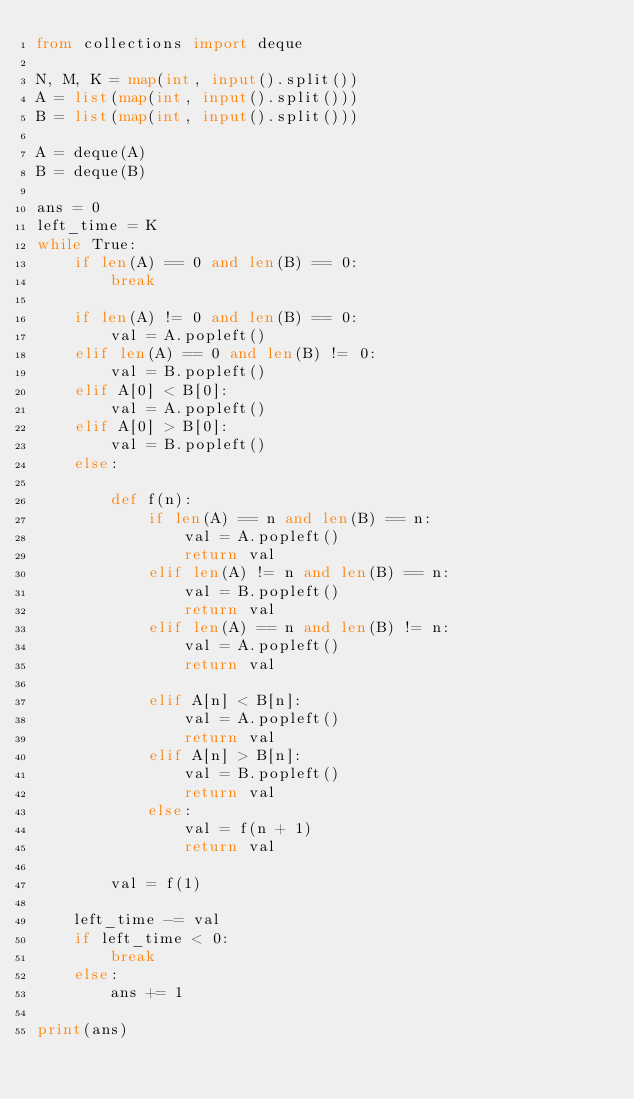Convert code to text. <code><loc_0><loc_0><loc_500><loc_500><_Python_>from collections import deque

N, M, K = map(int, input().split())
A = list(map(int, input().split()))
B = list(map(int, input().split()))

A = deque(A)
B = deque(B)

ans = 0
left_time = K
while True:
    if len(A) == 0 and len(B) == 0:
        break

    if len(A) != 0 and len(B) == 0:
        val = A.popleft()
    elif len(A) == 0 and len(B) != 0:
        val = B.popleft()
    elif A[0] < B[0]:
        val = A.popleft()
    elif A[0] > B[0]:
        val = B.popleft()
    else:

        def f(n):
            if len(A) == n and len(B) == n:
                val = A.popleft()
                return val
            elif len(A) != n and len(B) == n:
                val = B.popleft()
                return val
            elif len(A) == n and len(B) != n:
                val = A.popleft()
                return val

            elif A[n] < B[n]:
                val = A.popleft()
                return val
            elif A[n] > B[n]:
                val = B.popleft()
                return val
            else:
                val = f(n + 1)
                return val

        val = f(1)

    left_time -= val
    if left_time < 0:
        break
    else:
        ans += 1

print(ans)
</code> 